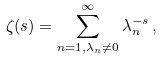<formula> <loc_0><loc_0><loc_500><loc_500>\zeta ( s ) = \sum _ { n = 1 , \lambda _ { n } \neq 0 } ^ { \infty } \lambda _ { n } ^ { - s } \, ,</formula> 